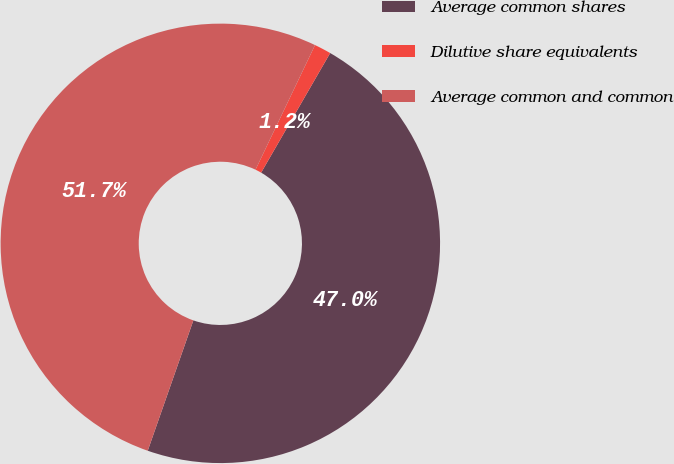Convert chart. <chart><loc_0><loc_0><loc_500><loc_500><pie_chart><fcel>Average common shares<fcel>Dilutive share equivalents<fcel>Average common and common<nl><fcel>47.03%<fcel>1.24%<fcel>51.73%<nl></chart> 